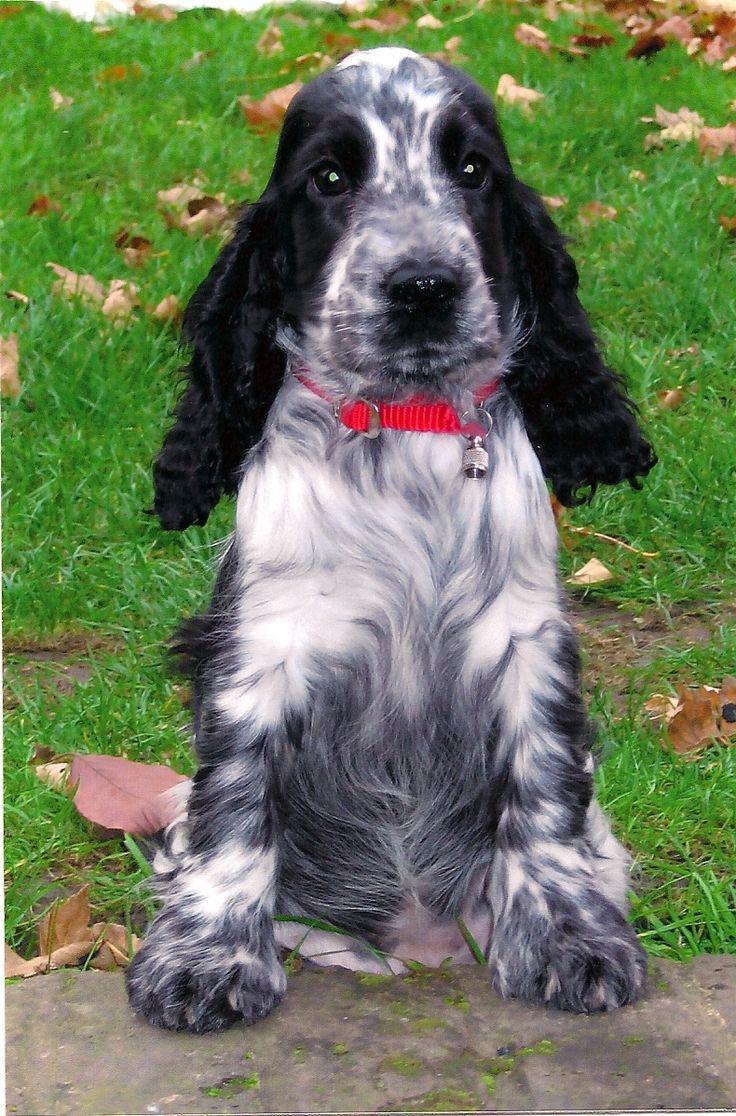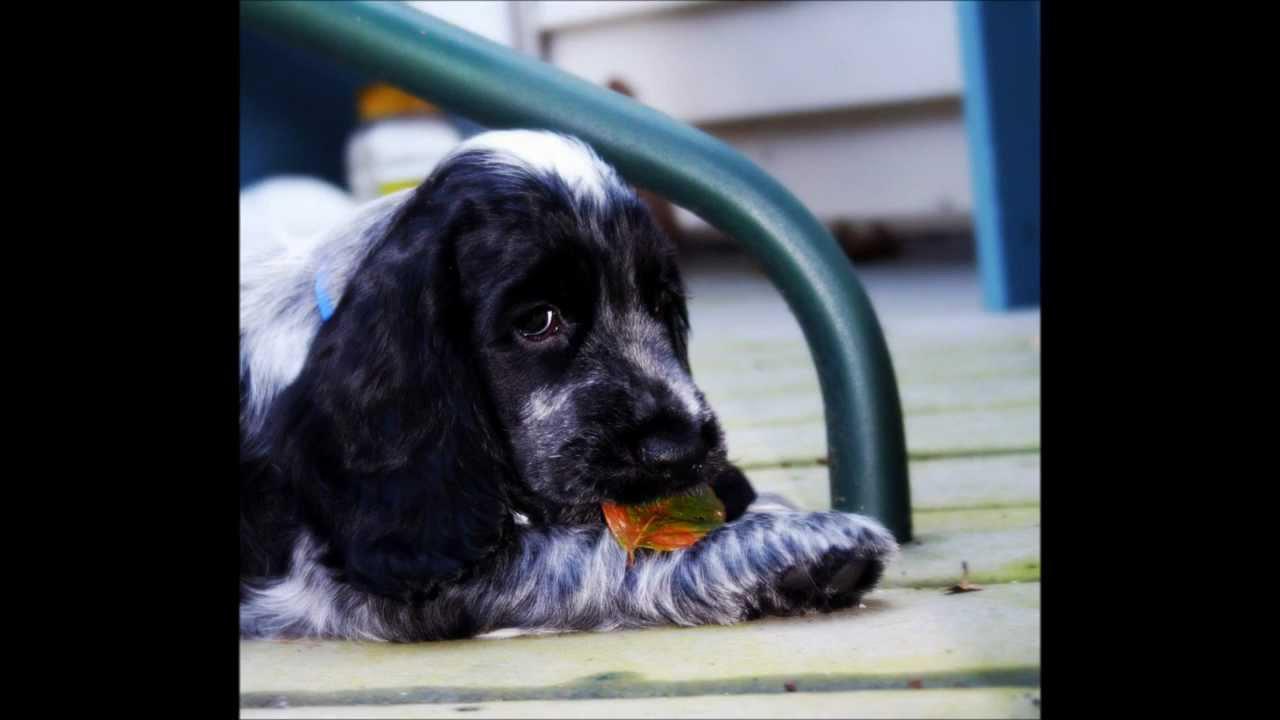The first image is the image on the left, the second image is the image on the right. Assess this claim about the two images: "One image shows a black-and-gray spaniel sitting upright, and the other image shows a brown spaniel holding a game bird in its mouth.". Correct or not? Answer yes or no. No. The first image is the image on the left, the second image is the image on the right. Given the left and right images, does the statement "An image contains a dog with a dead bird in its mouth." hold true? Answer yes or no. No. 